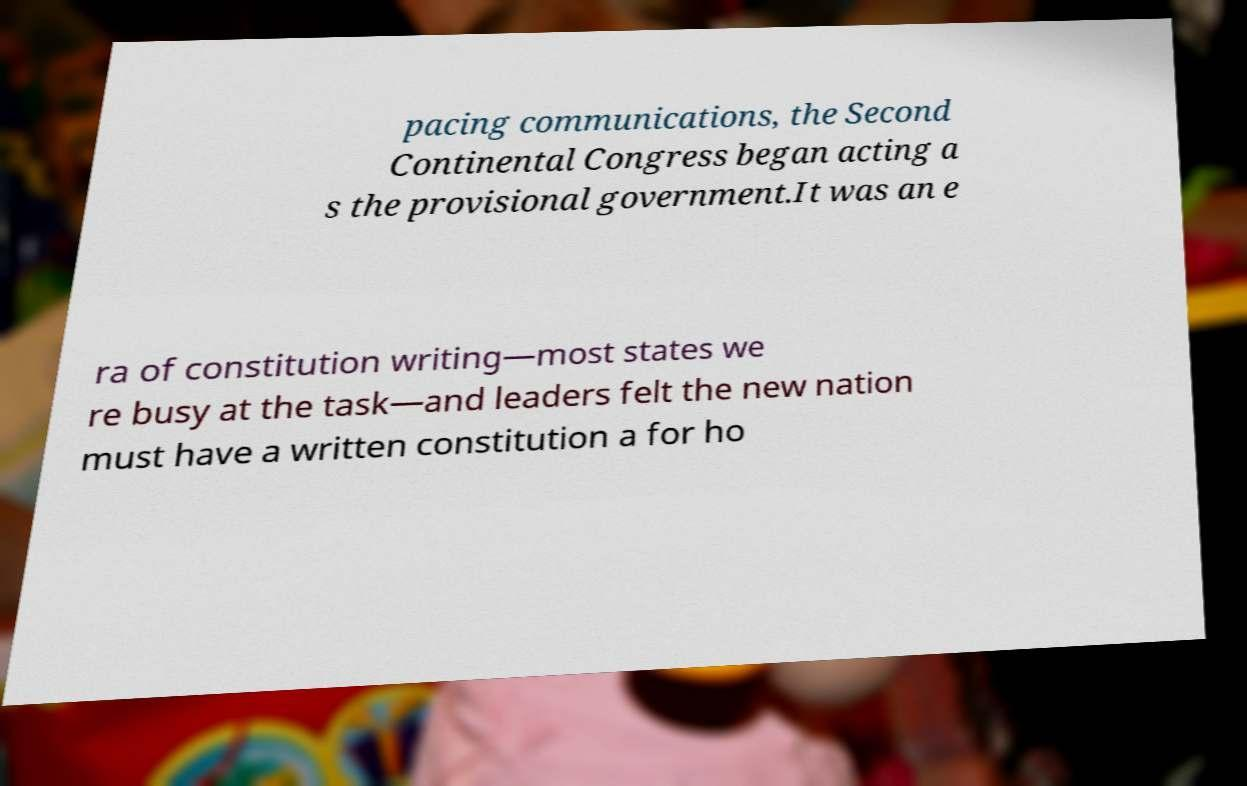For documentation purposes, I need the text within this image transcribed. Could you provide that? pacing communications, the Second Continental Congress began acting a s the provisional government.It was an e ra of constitution writing—most states we re busy at the task—and leaders felt the new nation must have a written constitution a for ho 